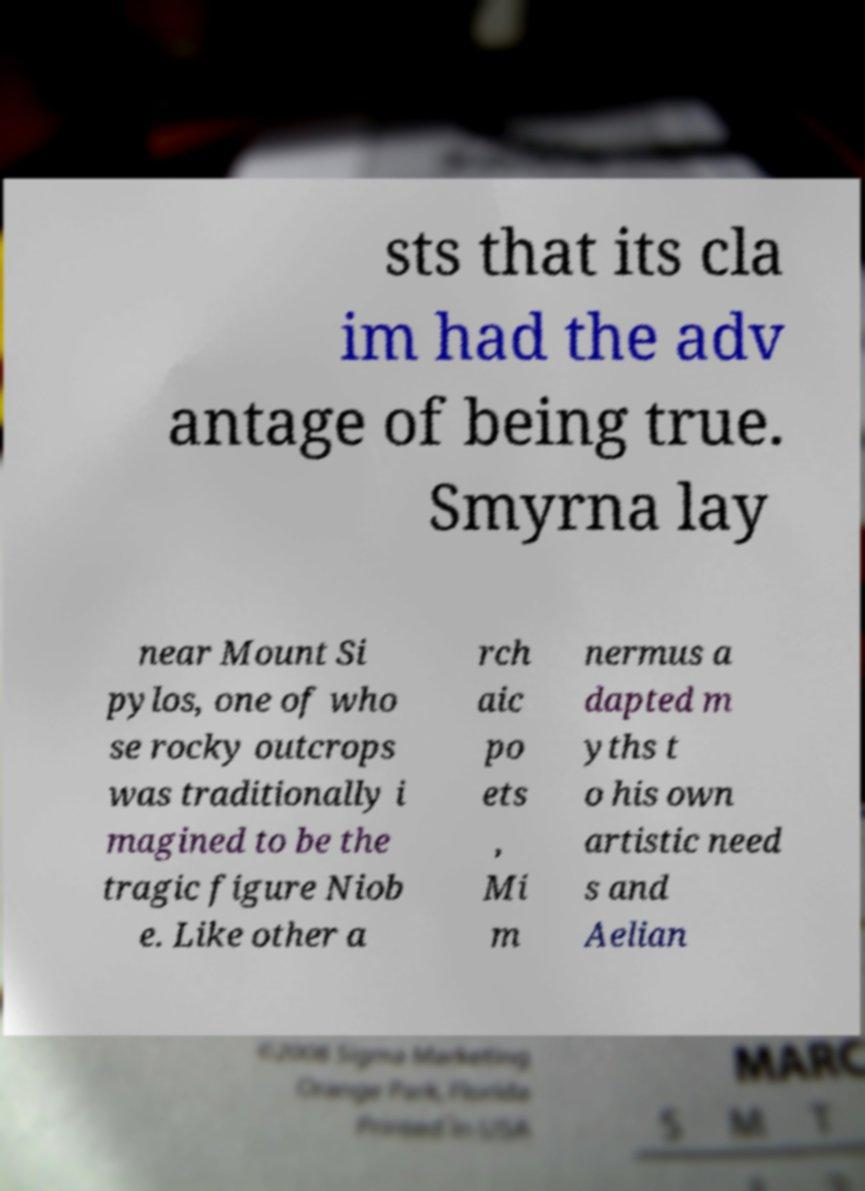Please identify and transcribe the text found in this image. sts that its cla im had the adv antage of being true. Smyrna lay near Mount Si pylos, one of who se rocky outcrops was traditionally i magined to be the tragic figure Niob e. Like other a rch aic po ets , Mi m nermus a dapted m yths t o his own artistic need s and Aelian 